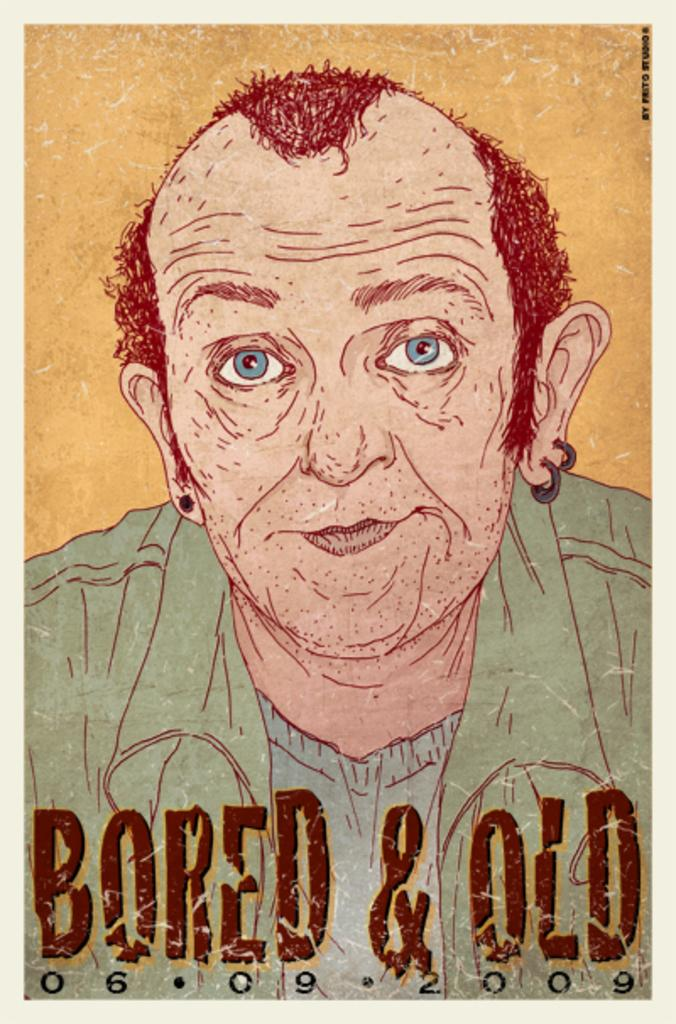Provide a one-sentence caption for the provided image. a cartoon photo that says bored and old. 